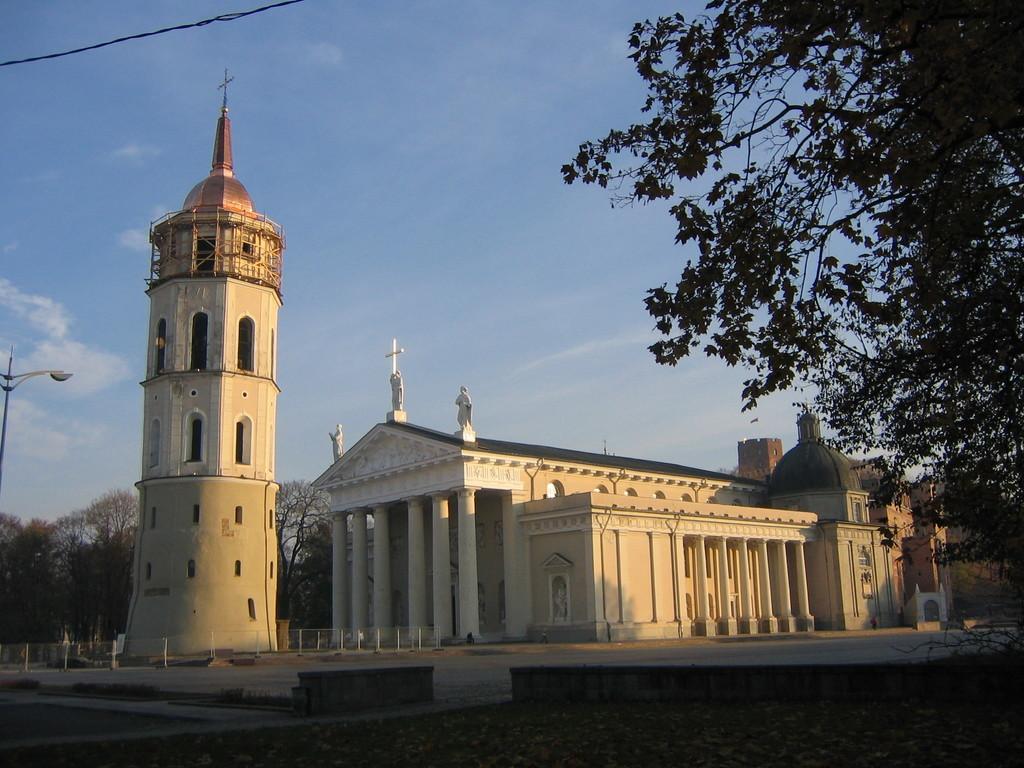Please provide a concise description of this image. There is a tower building with arches. On the top of that there is a cross. Near to the building there are railings. Also there is another building with pillars. On the top of the building there is a cross and statues. On the sides there are trees. On the left side there is a light pole. In the background there is sky with clouds. 